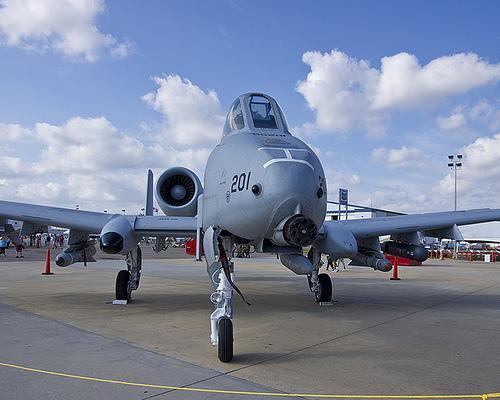How many planes are there?
Give a very brief answer. 1. 